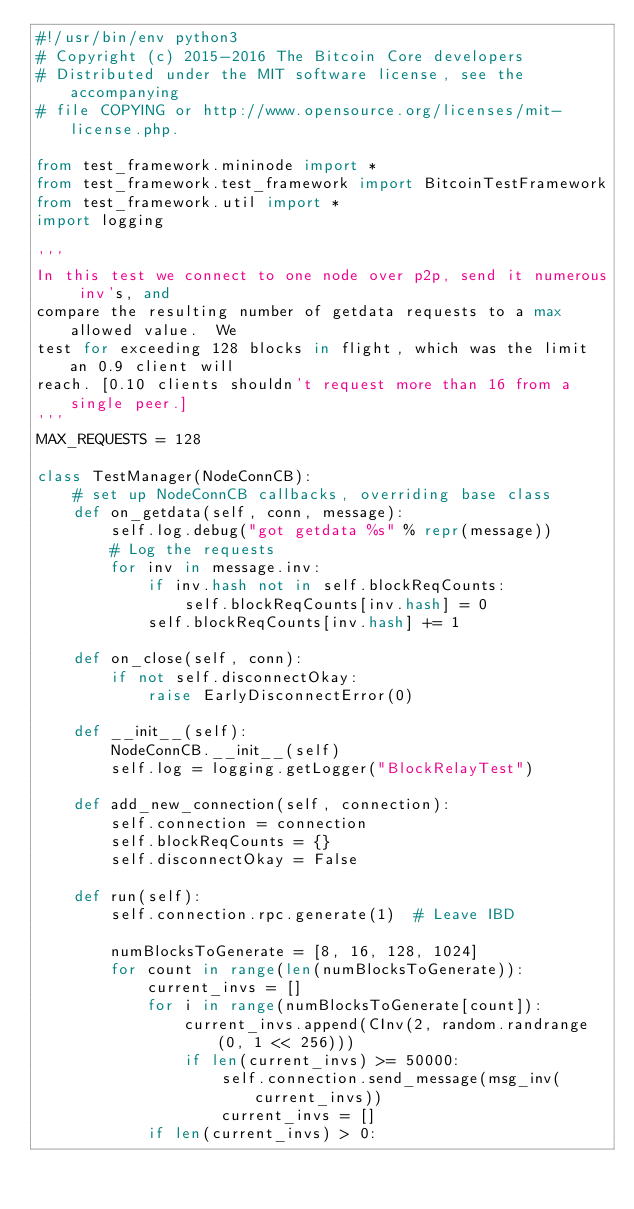<code> <loc_0><loc_0><loc_500><loc_500><_Python_>#!/usr/bin/env python3
# Copyright (c) 2015-2016 The Bitcoin Core developers
# Distributed under the MIT software license, see the accompanying
# file COPYING or http://www.opensource.org/licenses/mit-license.php.

from test_framework.mininode import *
from test_framework.test_framework import BitcoinTestFramework
from test_framework.util import *
import logging

'''
In this test we connect to one node over p2p, send it numerous inv's, and
compare the resulting number of getdata requests to a max allowed value.  We
test for exceeding 128 blocks in flight, which was the limit an 0.9 client will
reach. [0.10 clients shouldn't request more than 16 from a single peer.]
'''
MAX_REQUESTS = 128

class TestManager(NodeConnCB):
    # set up NodeConnCB callbacks, overriding base class
    def on_getdata(self, conn, message):
        self.log.debug("got getdata %s" % repr(message))
        # Log the requests
        for inv in message.inv:
            if inv.hash not in self.blockReqCounts:
                self.blockReqCounts[inv.hash] = 0
            self.blockReqCounts[inv.hash] += 1

    def on_close(self, conn):
        if not self.disconnectOkay:
            raise EarlyDisconnectError(0)

    def __init__(self):
        NodeConnCB.__init__(self)
        self.log = logging.getLogger("BlockRelayTest")

    def add_new_connection(self, connection):
        self.connection = connection
        self.blockReqCounts = {}
        self.disconnectOkay = False

    def run(self):
        self.connection.rpc.generate(1)  # Leave IBD

        numBlocksToGenerate = [8, 16, 128, 1024]
        for count in range(len(numBlocksToGenerate)):
            current_invs = []
            for i in range(numBlocksToGenerate[count]):
                current_invs.append(CInv(2, random.randrange(0, 1 << 256)))
                if len(current_invs) >= 50000:
                    self.connection.send_message(msg_inv(current_invs))
                    current_invs = []
            if len(current_invs) > 0:</code> 